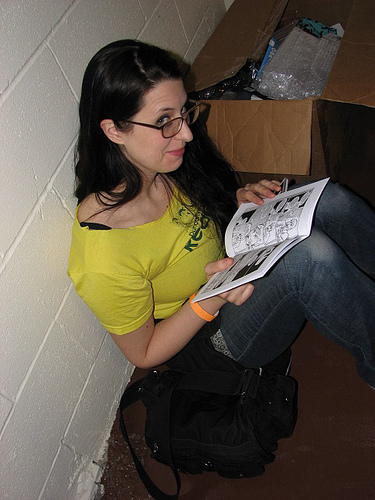<image>
Can you confirm if the glasses is on the box? No. The glasses is not positioned on the box. They may be near each other, but the glasses is not supported by or resting on top of the box. 